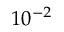Convert formula to latex. <formula><loc_0><loc_0><loc_500><loc_500>1 0 ^ { - 2 }</formula> 